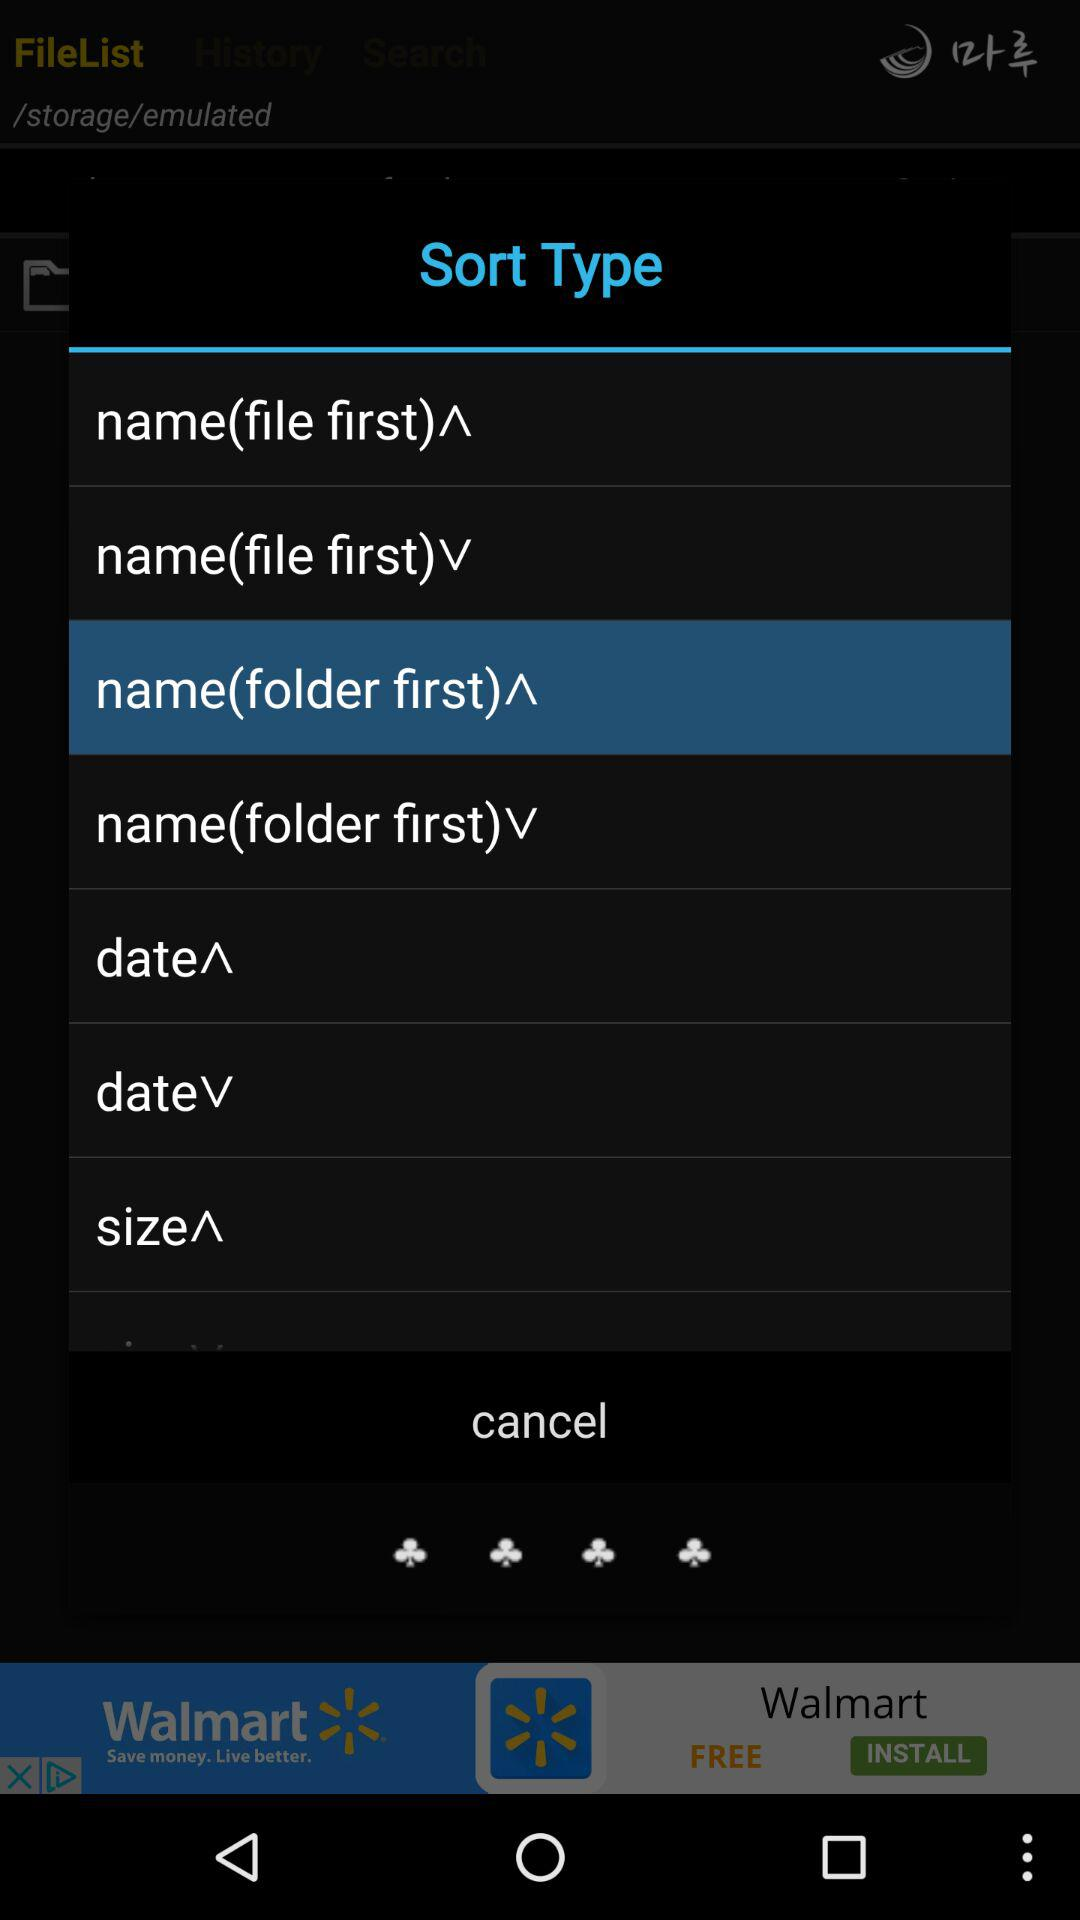Which type is selected? The selected type is "name(folder first)^". 